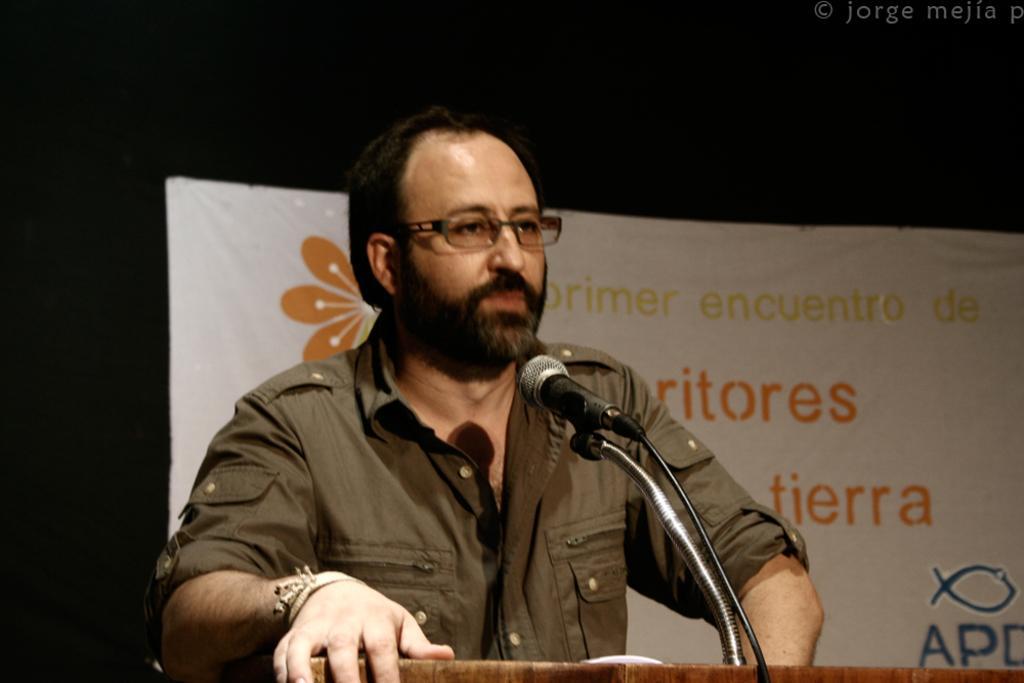Please provide a concise description of this image. In this image I can see a person wearing brown colored shirt is standing in front of the podium and I can see a microphone in front of him. I can see the white colored banner and the black colored background. 